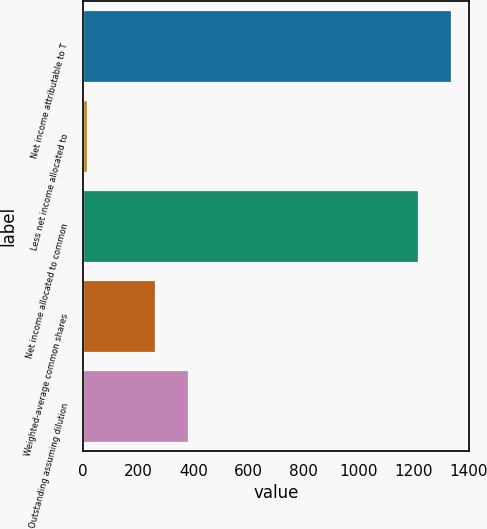Convert chart to OTSL. <chart><loc_0><loc_0><loc_500><loc_500><bar_chart><fcel>Net income attributable to T<fcel>Less net income allocated to<fcel>Net income allocated to common<fcel>Weighted-average common shares<fcel>Outstanding assuming dilution<nl><fcel>1336.94<fcel>14.2<fcel>1215.4<fcel>259.6<fcel>381.14<nl></chart> 